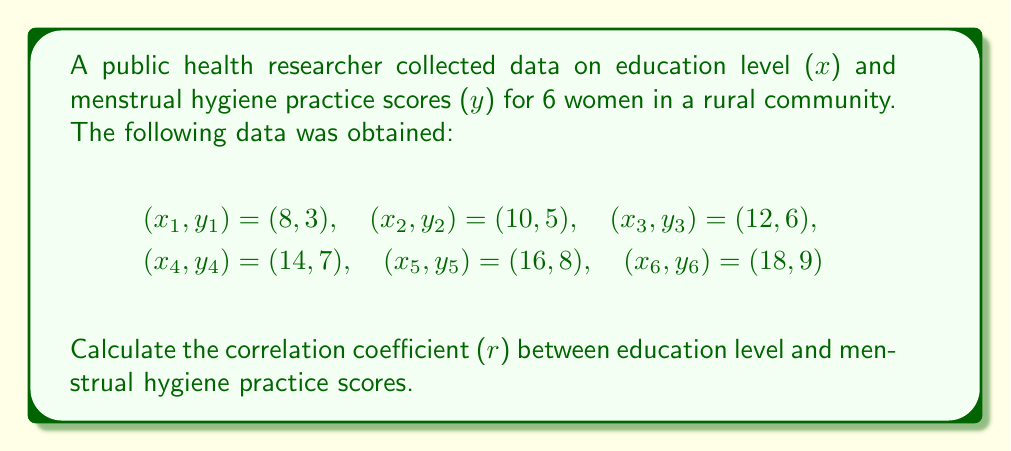Can you answer this question? To calculate the correlation coefficient (r), we'll use the formula:

$$ r = \frac{n\sum xy - (\sum x)(\sum y)}{\sqrt{[n\sum x^2 - (\sum x)^2][n\sum y^2 - (\sum y)^2]}} $$

Step 1: Calculate the sums and squared sums:
$\sum x = 8 + 10 + 12 + 14 + 16 + 18 = 78$
$\sum y = 3 + 5 + 6 + 7 + 8 + 9 = 38$
$\sum xy = (8 \times 3) + (10 \times 5) + (12 \times 6) + (14 \times 7) + (16 \times 8) + (18 \times 9) = 524$
$\sum x^2 = 8^2 + 10^2 + 12^2 + 14^2 + 16^2 + 18^2 = 1140$
$\sum y^2 = 3^2 + 5^2 + 6^2 + 7^2 + 8^2 + 9^2 = 260$

Step 2: Apply the formula:
$$ r = \frac{6(524) - (78)(38)}{\sqrt{[6(1140) - 78^2][6(260) - 38^2]}} $$

Step 3: Simplify:
$$ r = \frac{3144 - 2964}{\sqrt{(6840 - 6084)(1560 - 1444)}} $$

$$ r = \frac{180}{\sqrt{756 \times 116}} $$

$$ r = \frac{180}{\sqrt{87696}} $$

$$ r = \frac{180}{296.13} $$

$$ r \approx 0.9974 $$
Answer: $r \approx 0.9974$ 